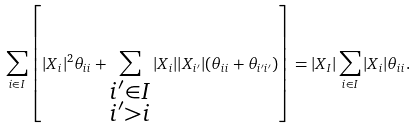Convert formula to latex. <formula><loc_0><loc_0><loc_500><loc_500>\sum _ { i \in I } \left [ | X _ { i } | ^ { 2 } \theta _ { i i } + \sum _ { \substack { i ^ { \prime } \in I \\ i ^ { \prime } > i } } | X _ { i } | | X _ { i ^ { \prime } } | ( \theta _ { i i } + \theta _ { i ^ { \prime } i ^ { \prime } } ) \right ] = | X _ { I } | \sum _ { i \in I } | X _ { i } | \theta _ { i i } .</formula> 